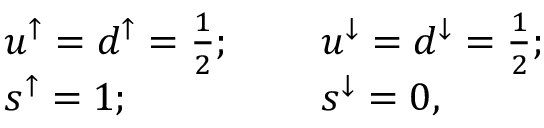<formula> <loc_0><loc_0><loc_500><loc_500>\begin{array} { c l l r & { { u ^ { \uparrow } = d ^ { \uparrow } = \frac { 1 } { 2 } ; } } & { { u ^ { \downarrow } = d ^ { \downarrow } = \frac { 1 } { 2 } ; } } & { { s ^ { \uparrow } = 1 ; } } & { { s ^ { \downarrow } = 0 , } } \end{array}</formula> 